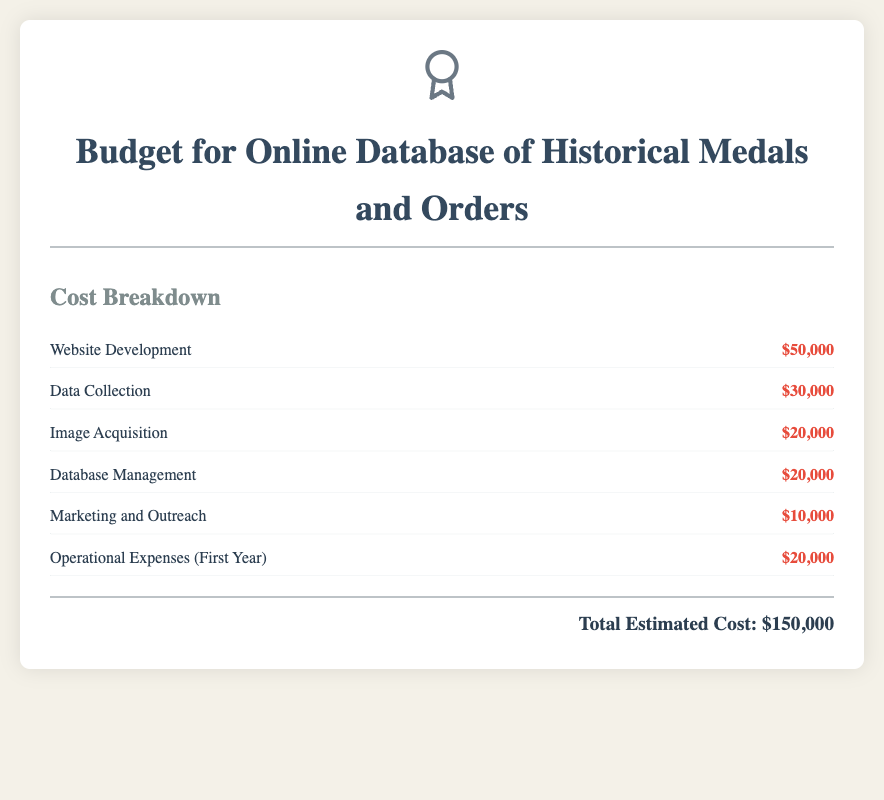What is the total estimated cost? The total estimated cost is presented at the bottom of the budget, summing all identified costs.
Answer: $150,000 How much is allocated for website development? The budget item for website development specifies an amount towards the overall project.
Answer: $50,000 What is the budget for data collection? The document explicitly lists the amount set aside for data collection in the cost breakdown section.
Answer: $30,000 How much is allocated for image acquisition? The budget item for image acquisition indicates the financial resources dedicated to obtaining images for the database.
Answer: $20,000 What percentage of the total cost is for marketing and outreach? To answer this, the marketing and outreach cost must be calculated as a percentage of the total estimated cost.
Answer: 6.67% What is the budget for operational expenses in the first year? The section outlines the amount directed towards operational expenses for the initial year of the project.
Answer: $20,000 What is the second highest cost in the budget? The second highest cost can be identified by comparing all listed costs and finding the next highest after the website development cost.
Answer: $30,000 What can be inferred about the database management cost? The database management cost is specified in the document as part of the total expenses for the project.
Answer: $20,000 How many total cost categories are listed in the budget? The document details each line item contributing to the total cost, which sums up various categories.
Answer: 6 